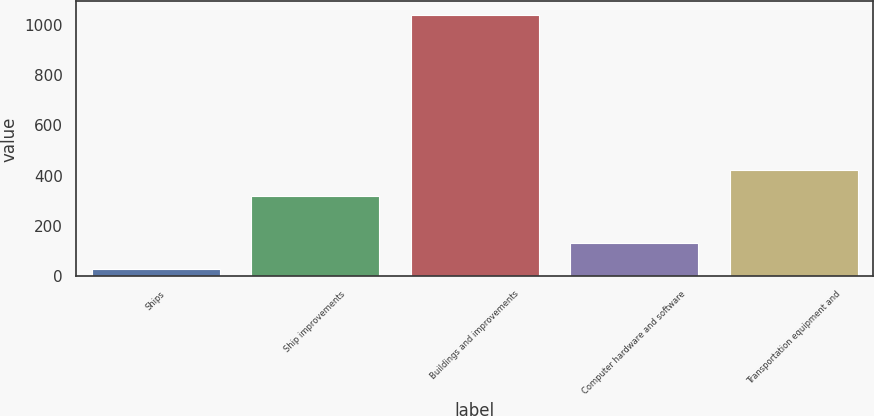Convert chart. <chart><loc_0><loc_0><loc_500><loc_500><bar_chart><fcel>Ships<fcel>Ship improvements<fcel>Buildings and improvements<fcel>Computer hardware and software<fcel>Transportation equipment and<nl><fcel>30<fcel>320<fcel>1040<fcel>131<fcel>421<nl></chart> 